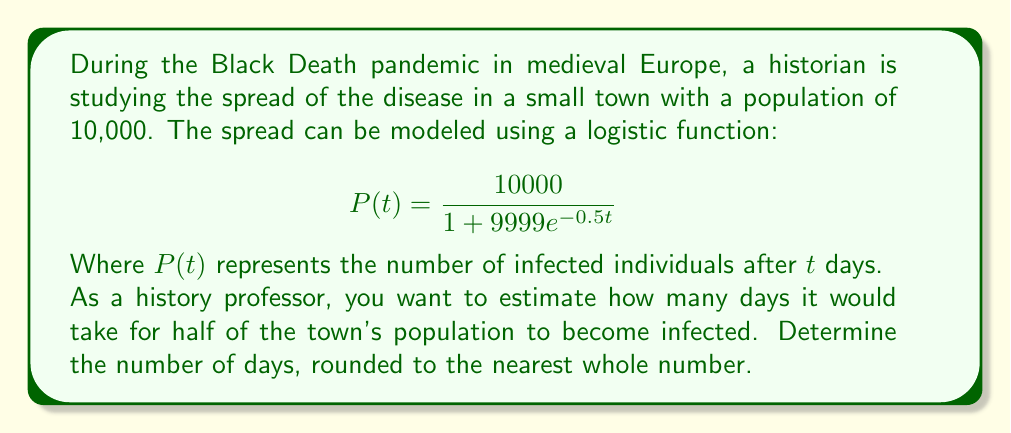Give your solution to this math problem. To solve this problem, we need to follow these steps:

1. Identify the target population: Half of the town's population is 5,000.

2. Set up the equation:
   $$ 5000 = \frac{10000}{1 + 9999e^{-0.5t}} $$

3. Solve for $t$:
   $$ 1 + 9999e^{-0.5t} = 2 $$
   $$ 9999e^{-0.5t} = 1 $$
   $$ e^{-0.5t} = \frac{1}{9999} $$

4. Take the natural logarithm of both sides:
   $$ -0.5t = \ln(\frac{1}{9999}) $$
   $$ -0.5t = -\ln(9999) $$

5. Solve for $t$:
   $$ t = \frac{\ln(9999)}{0.5} $$
   $$ t \approx 18.42 $$

6. Round to the nearest whole number:
   $$ t \approx 18 \text{ days} $$

This approach allows us to estimate the spread of the disease using a mathematical model, which can be valuable for historical analysis of pandemics.
Answer: 18 days 